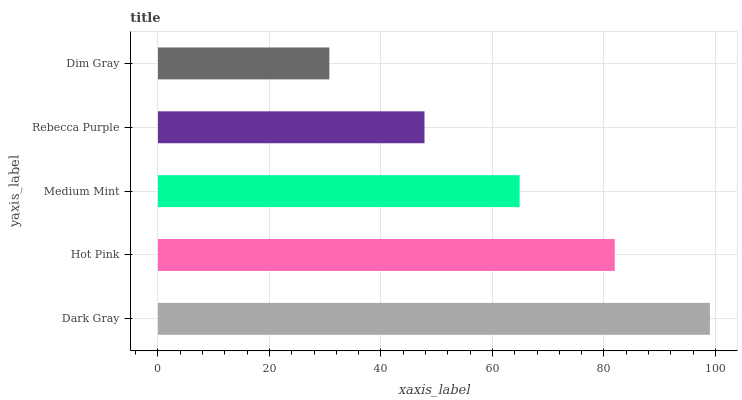Is Dim Gray the minimum?
Answer yes or no. Yes. Is Dark Gray the maximum?
Answer yes or no. Yes. Is Hot Pink the minimum?
Answer yes or no. No. Is Hot Pink the maximum?
Answer yes or no. No. Is Dark Gray greater than Hot Pink?
Answer yes or no. Yes. Is Hot Pink less than Dark Gray?
Answer yes or no. Yes. Is Hot Pink greater than Dark Gray?
Answer yes or no. No. Is Dark Gray less than Hot Pink?
Answer yes or no. No. Is Medium Mint the high median?
Answer yes or no. Yes. Is Medium Mint the low median?
Answer yes or no. Yes. Is Dark Gray the high median?
Answer yes or no. No. Is Dim Gray the low median?
Answer yes or no. No. 